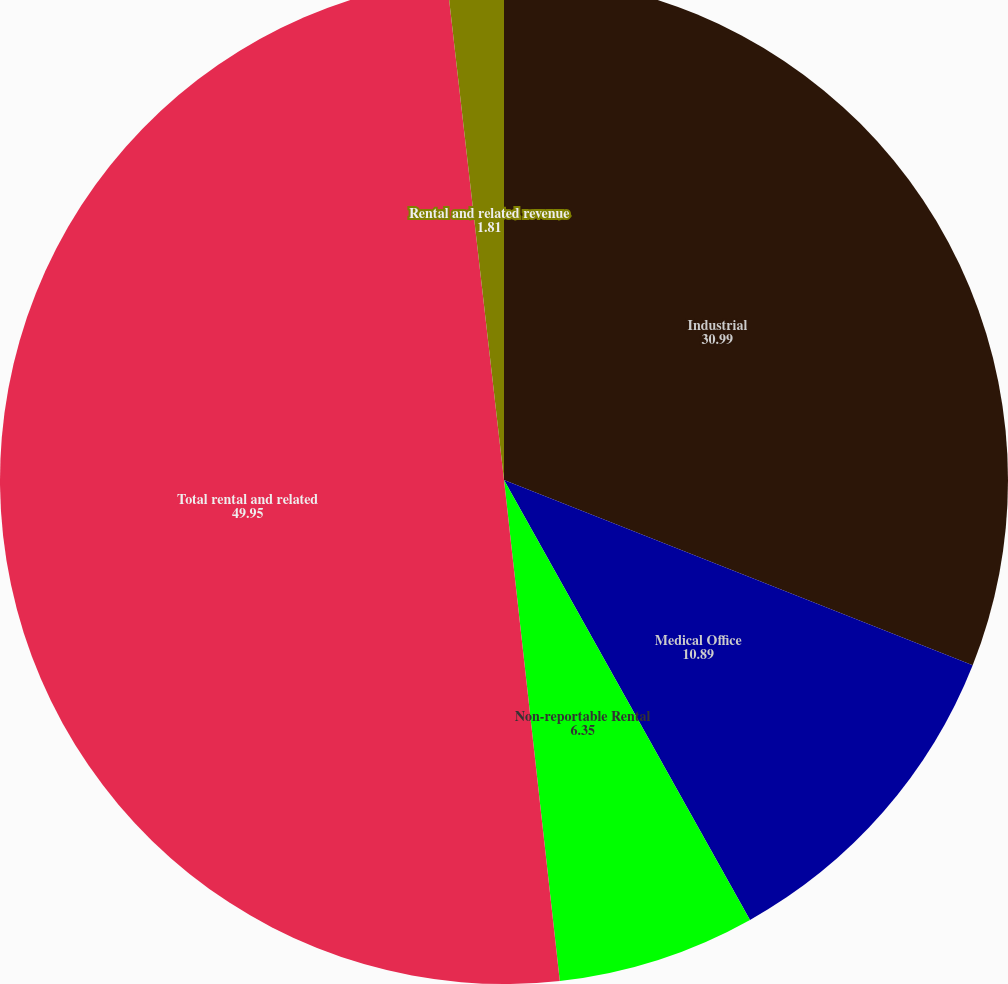Convert chart. <chart><loc_0><loc_0><loc_500><loc_500><pie_chart><fcel>Industrial<fcel>Medical Office<fcel>Non-reportable Rental<fcel>Total rental and related<fcel>Rental and related revenue<nl><fcel>30.99%<fcel>10.89%<fcel>6.35%<fcel>49.95%<fcel>1.81%<nl></chart> 